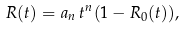Convert formula to latex. <formula><loc_0><loc_0><loc_500><loc_500>R ( t ) = a _ { n } \, t ^ { n } ( 1 - R _ { 0 } ( t ) ) ,</formula> 